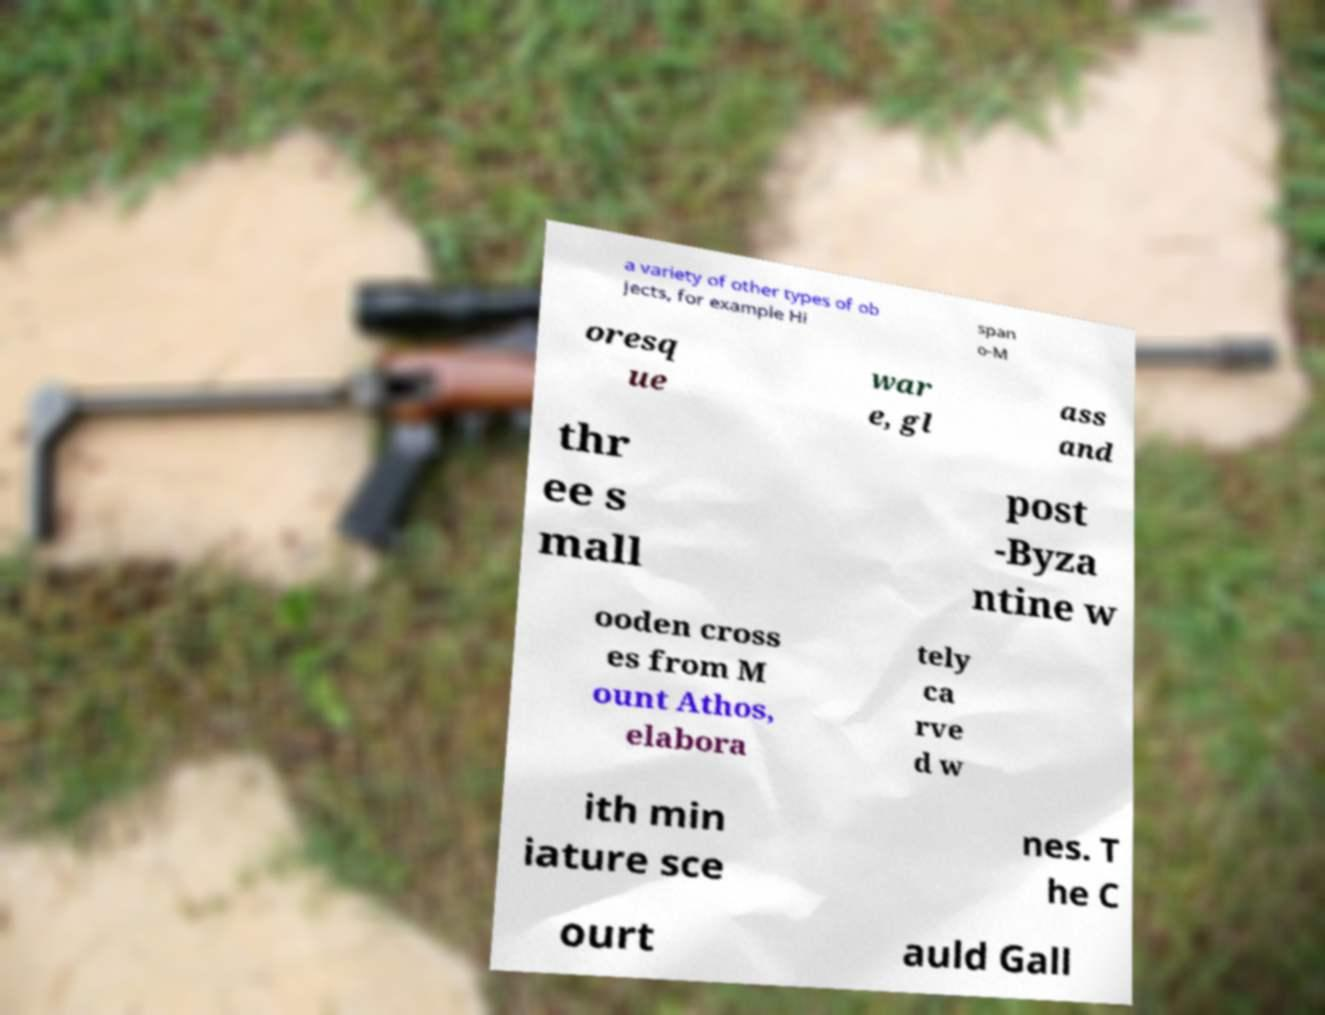I need the written content from this picture converted into text. Can you do that? a variety of other types of ob jects, for example Hi span o-M oresq ue war e, gl ass and thr ee s mall post -Byza ntine w ooden cross es from M ount Athos, elabora tely ca rve d w ith min iature sce nes. T he C ourt auld Gall 